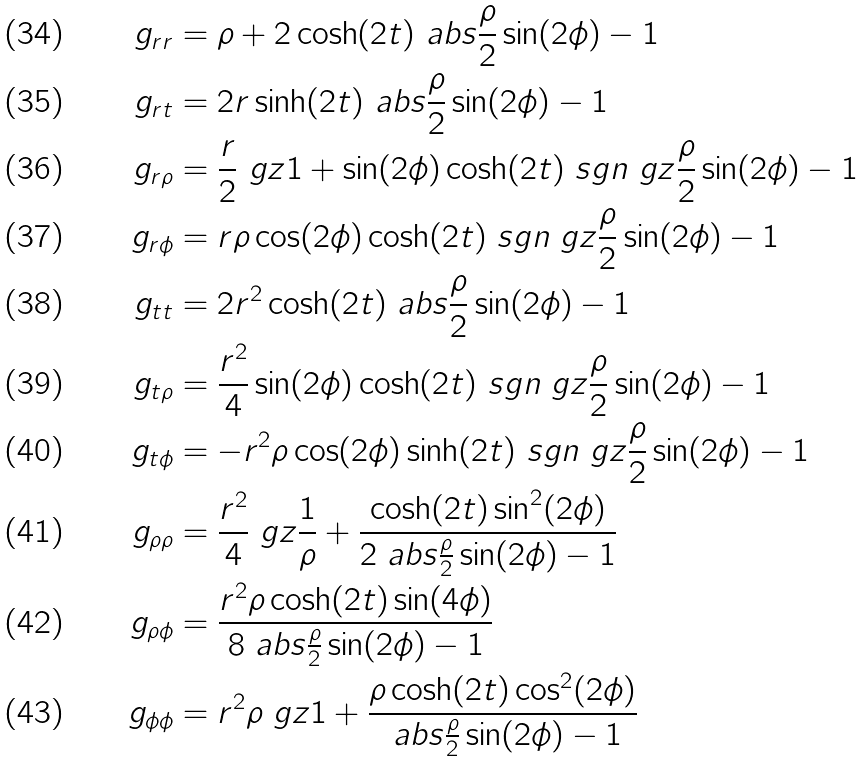Convert formula to latex. <formula><loc_0><loc_0><loc_500><loc_500>g _ { r r } & = \rho + 2 \cosh ( 2 t ) \ a b s { \frac { \rho } { 2 } \sin ( 2 \phi ) - 1 } \\ g _ { r t } & = 2 r \sinh ( 2 t ) \ a b s { \frac { \rho } { 2 } \sin ( 2 \phi ) - 1 } \\ g _ { r \rho } & = \frac { r } { 2 } \ g z { 1 + \sin ( 2 \phi ) \cosh ( 2 t ) \ s g n \ g z { \frac { \rho } { 2 } \sin ( 2 \phi ) - 1 } } \\ g _ { r \phi } & = r \rho \cos ( 2 \phi ) \cosh ( 2 t ) \ s g n \ g z { \frac { \rho } { 2 } \sin ( 2 \phi ) - 1 } \\ g _ { t t } & = 2 r ^ { 2 } \cosh ( 2 t ) \ a b s { \frac { \rho } { 2 } \sin ( 2 \phi ) - 1 } \\ g _ { t \rho } & = \frac { r ^ { 2 } } { 4 } \sin ( 2 \phi ) \cosh ( 2 t ) \ s g n \ g z { \frac { \rho } { 2 } \sin ( 2 \phi ) - 1 } \\ g _ { t \phi } & = - r ^ { 2 } \rho \cos ( 2 \phi ) \sinh ( 2 t ) \ s g n \ g z { \frac { \rho } { 2 } \sin ( 2 \phi ) - 1 } \\ g _ { \rho \rho } & = \frac { r ^ { 2 } } { 4 } \ g z { \frac { 1 } { \rho } + \frac { \cosh ( 2 t ) \sin ^ { 2 } ( 2 \phi ) } { 2 \ a b s { \frac { \rho } { 2 } \sin ( 2 \phi ) - 1 } } } \\ g _ { \rho \phi } & = \frac { r ^ { 2 } \rho \cosh ( 2 t ) \sin ( 4 \phi ) } { 8 \ a b s { \frac { \rho } { 2 } \sin ( 2 \phi ) - 1 } } \\ g _ { \phi \phi } & = r ^ { 2 } \rho \ g z { 1 + \frac { \rho \cosh ( 2 t ) \cos ^ { 2 } ( 2 \phi ) } { \ a b s { \frac { \rho } { 2 } \sin ( 2 \phi ) - 1 } } }</formula> 